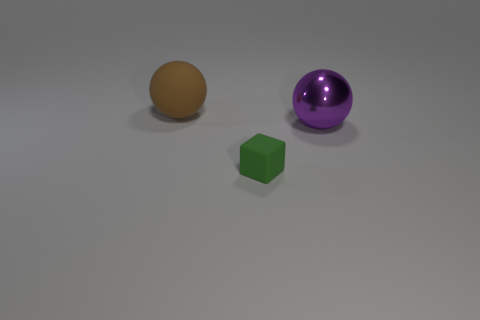Add 3 small objects. How many objects exist? 6 Subtract all balls. How many objects are left? 1 Subtract 0 cyan cubes. How many objects are left? 3 Subtract all small matte blocks. Subtract all large purple metallic balls. How many objects are left? 1 Add 1 large shiny spheres. How many large shiny spheres are left? 2 Add 1 green matte objects. How many green matte objects exist? 2 